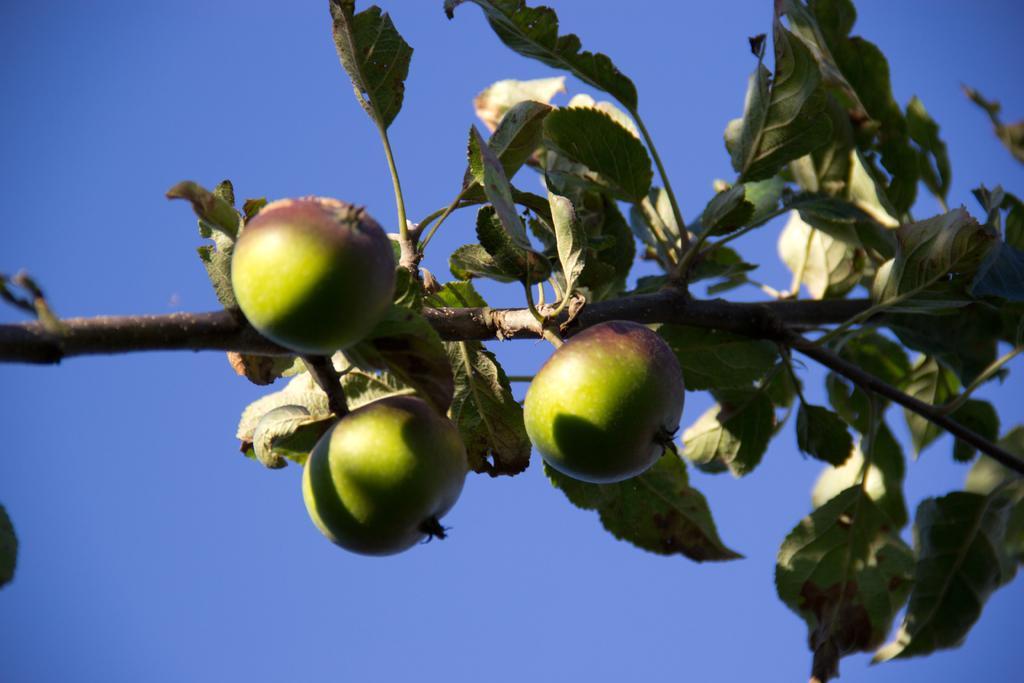Please provide a concise description of this image. In this image I can see the fruits to the plant. I can see these fruits are in green and brown color and there is a blue background. 